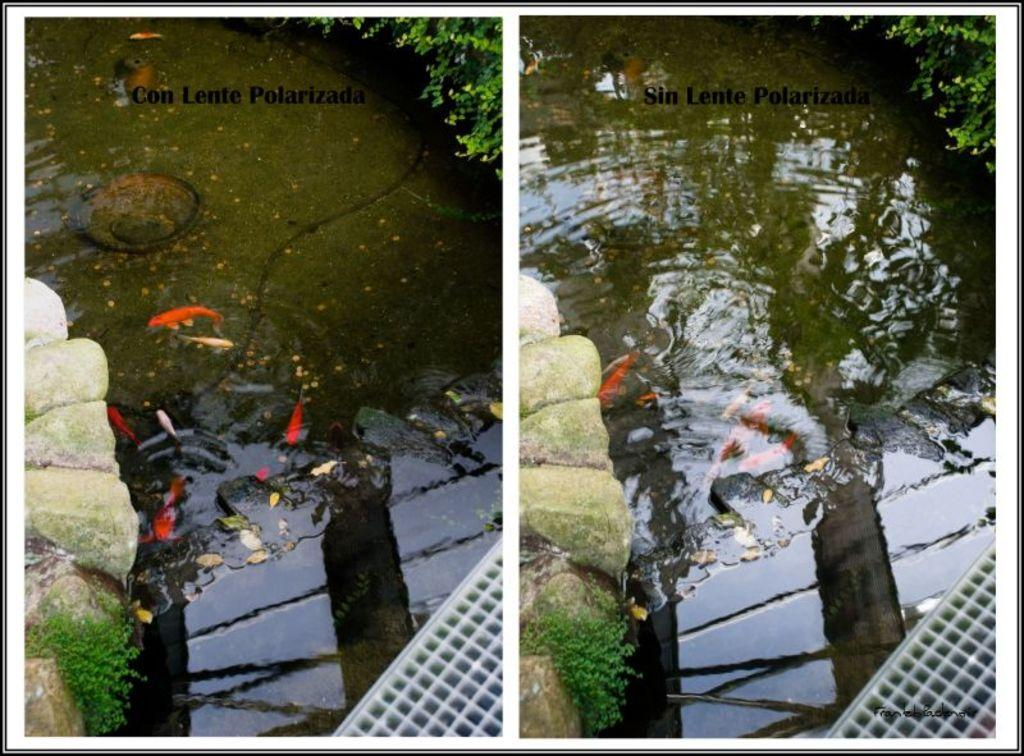What can be found on the left side of the image? There are rocks on the left side of the image. What is located in the middle of the image? There is water in the middle of the image. Where is the plant situated in the image? The plant is in the top right hand corner of the image. What type of match is being played in the image? There is no match being played in the image; it features rocks, water, and a plant. What kind of bean is growing near the rocks in the image? There are no beans present in the image; it only features rocks, water, and a plant. 